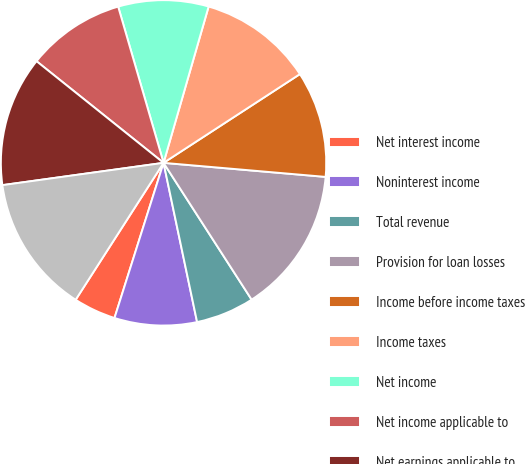Convert chart to OTSL. <chart><loc_0><loc_0><loc_500><loc_500><pie_chart><fcel>Net interest income<fcel>Noninterest income<fcel>Total revenue<fcel>Provision for loan losses<fcel>Income before income taxes<fcel>Income taxes<fcel>Net income<fcel>Net income applicable to<fcel>Net earnings applicable to<fcel>Net earnings - diluted<nl><fcel>4.21%<fcel>8.18%<fcel>5.8%<fcel>14.52%<fcel>10.56%<fcel>11.35%<fcel>8.97%<fcel>9.76%<fcel>12.93%<fcel>13.73%<nl></chart> 